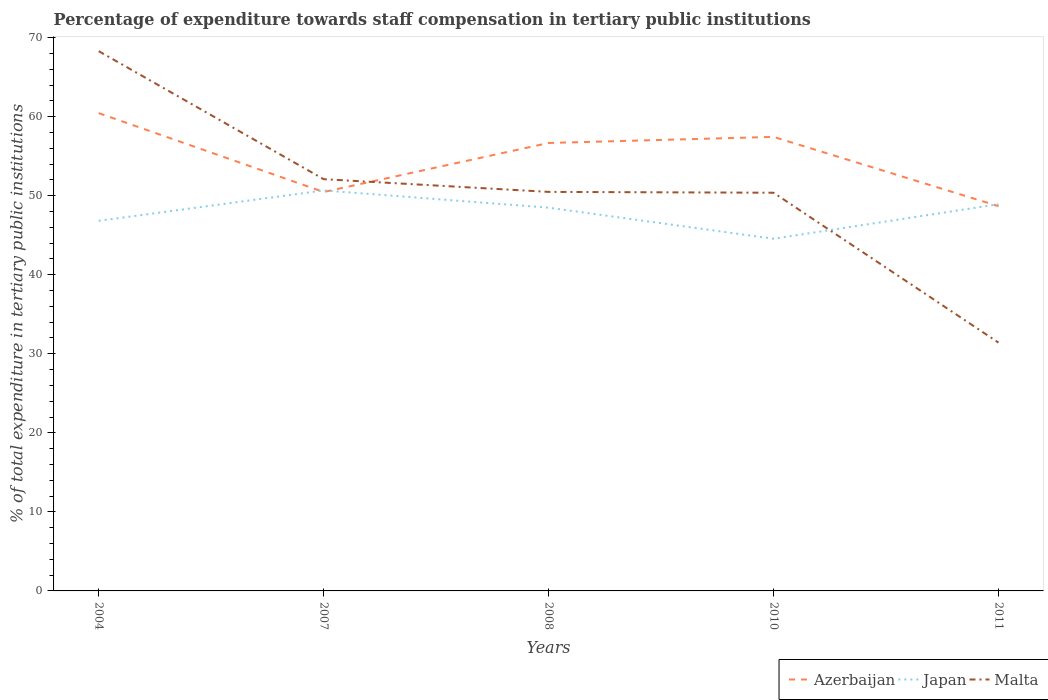How many different coloured lines are there?
Keep it short and to the point. 3. Does the line corresponding to Azerbaijan intersect with the line corresponding to Japan?
Provide a short and direct response. Yes. Is the number of lines equal to the number of legend labels?
Keep it short and to the point. Yes. Across all years, what is the maximum percentage of expenditure towards staff compensation in Malta?
Keep it short and to the point. 31.41. In which year was the percentage of expenditure towards staff compensation in Japan maximum?
Your response must be concise. 2010. What is the total percentage of expenditure towards staff compensation in Azerbaijan in the graph?
Offer a terse response. -6.2. What is the difference between the highest and the second highest percentage of expenditure towards staff compensation in Malta?
Offer a terse response. 36.88. What is the difference between the highest and the lowest percentage of expenditure towards staff compensation in Japan?
Give a very brief answer. 3. Is the percentage of expenditure towards staff compensation in Malta strictly greater than the percentage of expenditure towards staff compensation in Japan over the years?
Give a very brief answer. No. How many lines are there?
Offer a terse response. 3. How many years are there in the graph?
Your answer should be compact. 5. What is the difference between two consecutive major ticks on the Y-axis?
Provide a short and direct response. 10. Where does the legend appear in the graph?
Give a very brief answer. Bottom right. How many legend labels are there?
Your answer should be very brief. 3. What is the title of the graph?
Make the answer very short. Percentage of expenditure towards staff compensation in tertiary public institutions. Does "Bahamas" appear as one of the legend labels in the graph?
Your response must be concise. No. What is the label or title of the X-axis?
Offer a very short reply. Years. What is the label or title of the Y-axis?
Your answer should be compact. % of total expenditure in tertiary public institutions. What is the % of total expenditure in tertiary public institutions of Azerbaijan in 2004?
Give a very brief answer. 60.45. What is the % of total expenditure in tertiary public institutions of Japan in 2004?
Offer a very short reply. 46.82. What is the % of total expenditure in tertiary public institutions in Malta in 2004?
Give a very brief answer. 68.29. What is the % of total expenditure in tertiary public institutions of Azerbaijan in 2007?
Make the answer very short. 50.47. What is the % of total expenditure in tertiary public institutions in Japan in 2007?
Your answer should be very brief. 50.67. What is the % of total expenditure in tertiary public institutions in Malta in 2007?
Make the answer very short. 52.09. What is the % of total expenditure in tertiary public institutions of Azerbaijan in 2008?
Ensure brevity in your answer.  56.67. What is the % of total expenditure in tertiary public institutions in Japan in 2008?
Give a very brief answer. 48.49. What is the % of total expenditure in tertiary public institutions of Malta in 2008?
Offer a terse response. 50.48. What is the % of total expenditure in tertiary public institutions in Azerbaijan in 2010?
Offer a very short reply. 57.44. What is the % of total expenditure in tertiary public institutions of Japan in 2010?
Provide a short and direct response. 44.56. What is the % of total expenditure in tertiary public institutions in Malta in 2010?
Make the answer very short. 50.38. What is the % of total expenditure in tertiary public institutions in Azerbaijan in 2011?
Offer a very short reply. 48.68. What is the % of total expenditure in tertiary public institutions in Japan in 2011?
Your answer should be compact. 48.92. What is the % of total expenditure in tertiary public institutions of Malta in 2011?
Give a very brief answer. 31.41. Across all years, what is the maximum % of total expenditure in tertiary public institutions of Azerbaijan?
Provide a succinct answer. 60.45. Across all years, what is the maximum % of total expenditure in tertiary public institutions of Japan?
Offer a very short reply. 50.67. Across all years, what is the maximum % of total expenditure in tertiary public institutions in Malta?
Keep it short and to the point. 68.29. Across all years, what is the minimum % of total expenditure in tertiary public institutions of Azerbaijan?
Keep it short and to the point. 48.68. Across all years, what is the minimum % of total expenditure in tertiary public institutions of Japan?
Ensure brevity in your answer.  44.56. Across all years, what is the minimum % of total expenditure in tertiary public institutions in Malta?
Make the answer very short. 31.41. What is the total % of total expenditure in tertiary public institutions of Azerbaijan in the graph?
Keep it short and to the point. 273.71. What is the total % of total expenditure in tertiary public institutions in Japan in the graph?
Make the answer very short. 239.46. What is the total % of total expenditure in tertiary public institutions of Malta in the graph?
Provide a short and direct response. 252.66. What is the difference between the % of total expenditure in tertiary public institutions of Azerbaijan in 2004 and that in 2007?
Your answer should be compact. 9.98. What is the difference between the % of total expenditure in tertiary public institutions of Japan in 2004 and that in 2007?
Offer a terse response. -3.84. What is the difference between the % of total expenditure in tertiary public institutions in Malta in 2004 and that in 2007?
Your answer should be compact. 16.2. What is the difference between the % of total expenditure in tertiary public institutions of Azerbaijan in 2004 and that in 2008?
Give a very brief answer. 3.78. What is the difference between the % of total expenditure in tertiary public institutions of Japan in 2004 and that in 2008?
Make the answer very short. -1.66. What is the difference between the % of total expenditure in tertiary public institutions of Malta in 2004 and that in 2008?
Provide a short and direct response. 17.81. What is the difference between the % of total expenditure in tertiary public institutions of Azerbaijan in 2004 and that in 2010?
Keep it short and to the point. 3.01. What is the difference between the % of total expenditure in tertiary public institutions of Japan in 2004 and that in 2010?
Offer a very short reply. 2.27. What is the difference between the % of total expenditure in tertiary public institutions of Malta in 2004 and that in 2010?
Your response must be concise. 17.91. What is the difference between the % of total expenditure in tertiary public institutions of Azerbaijan in 2004 and that in 2011?
Offer a very short reply. 11.77. What is the difference between the % of total expenditure in tertiary public institutions in Japan in 2004 and that in 2011?
Give a very brief answer. -2.1. What is the difference between the % of total expenditure in tertiary public institutions in Malta in 2004 and that in 2011?
Give a very brief answer. 36.88. What is the difference between the % of total expenditure in tertiary public institutions in Azerbaijan in 2007 and that in 2008?
Offer a very short reply. -6.2. What is the difference between the % of total expenditure in tertiary public institutions in Japan in 2007 and that in 2008?
Your answer should be compact. 2.18. What is the difference between the % of total expenditure in tertiary public institutions in Malta in 2007 and that in 2008?
Your answer should be compact. 1.61. What is the difference between the % of total expenditure in tertiary public institutions of Azerbaijan in 2007 and that in 2010?
Your response must be concise. -6.97. What is the difference between the % of total expenditure in tertiary public institutions of Japan in 2007 and that in 2010?
Provide a succinct answer. 6.11. What is the difference between the % of total expenditure in tertiary public institutions in Malta in 2007 and that in 2010?
Offer a terse response. 1.72. What is the difference between the % of total expenditure in tertiary public institutions in Azerbaijan in 2007 and that in 2011?
Make the answer very short. 1.79. What is the difference between the % of total expenditure in tertiary public institutions of Japan in 2007 and that in 2011?
Keep it short and to the point. 1.74. What is the difference between the % of total expenditure in tertiary public institutions in Malta in 2007 and that in 2011?
Ensure brevity in your answer.  20.68. What is the difference between the % of total expenditure in tertiary public institutions of Azerbaijan in 2008 and that in 2010?
Your answer should be very brief. -0.77. What is the difference between the % of total expenditure in tertiary public institutions of Japan in 2008 and that in 2010?
Your response must be concise. 3.93. What is the difference between the % of total expenditure in tertiary public institutions in Malta in 2008 and that in 2010?
Offer a very short reply. 0.11. What is the difference between the % of total expenditure in tertiary public institutions in Azerbaijan in 2008 and that in 2011?
Give a very brief answer. 7.99. What is the difference between the % of total expenditure in tertiary public institutions in Japan in 2008 and that in 2011?
Offer a very short reply. -0.44. What is the difference between the % of total expenditure in tertiary public institutions of Malta in 2008 and that in 2011?
Provide a short and direct response. 19.07. What is the difference between the % of total expenditure in tertiary public institutions in Azerbaijan in 2010 and that in 2011?
Your answer should be very brief. 8.76. What is the difference between the % of total expenditure in tertiary public institutions in Japan in 2010 and that in 2011?
Ensure brevity in your answer.  -4.37. What is the difference between the % of total expenditure in tertiary public institutions of Malta in 2010 and that in 2011?
Ensure brevity in your answer.  18.96. What is the difference between the % of total expenditure in tertiary public institutions in Azerbaijan in 2004 and the % of total expenditure in tertiary public institutions in Japan in 2007?
Provide a short and direct response. 9.78. What is the difference between the % of total expenditure in tertiary public institutions in Azerbaijan in 2004 and the % of total expenditure in tertiary public institutions in Malta in 2007?
Provide a short and direct response. 8.36. What is the difference between the % of total expenditure in tertiary public institutions in Japan in 2004 and the % of total expenditure in tertiary public institutions in Malta in 2007?
Your answer should be very brief. -5.27. What is the difference between the % of total expenditure in tertiary public institutions of Azerbaijan in 2004 and the % of total expenditure in tertiary public institutions of Japan in 2008?
Provide a short and direct response. 11.96. What is the difference between the % of total expenditure in tertiary public institutions in Azerbaijan in 2004 and the % of total expenditure in tertiary public institutions in Malta in 2008?
Give a very brief answer. 9.97. What is the difference between the % of total expenditure in tertiary public institutions in Japan in 2004 and the % of total expenditure in tertiary public institutions in Malta in 2008?
Provide a succinct answer. -3.66. What is the difference between the % of total expenditure in tertiary public institutions in Azerbaijan in 2004 and the % of total expenditure in tertiary public institutions in Japan in 2010?
Offer a terse response. 15.89. What is the difference between the % of total expenditure in tertiary public institutions of Azerbaijan in 2004 and the % of total expenditure in tertiary public institutions of Malta in 2010?
Give a very brief answer. 10.07. What is the difference between the % of total expenditure in tertiary public institutions in Japan in 2004 and the % of total expenditure in tertiary public institutions in Malta in 2010?
Your answer should be compact. -3.55. What is the difference between the % of total expenditure in tertiary public institutions of Azerbaijan in 2004 and the % of total expenditure in tertiary public institutions of Japan in 2011?
Your response must be concise. 11.53. What is the difference between the % of total expenditure in tertiary public institutions of Azerbaijan in 2004 and the % of total expenditure in tertiary public institutions of Malta in 2011?
Provide a short and direct response. 29.04. What is the difference between the % of total expenditure in tertiary public institutions of Japan in 2004 and the % of total expenditure in tertiary public institutions of Malta in 2011?
Keep it short and to the point. 15.41. What is the difference between the % of total expenditure in tertiary public institutions of Azerbaijan in 2007 and the % of total expenditure in tertiary public institutions of Japan in 2008?
Your answer should be compact. 1.98. What is the difference between the % of total expenditure in tertiary public institutions in Azerbaijan in 2007 and the % of total expenditure in tertiary public institutions in Malta in 2008?
Your answer should be very brief. -0.01. What is the difference between the % of total expenditure in tertiary public institutions of Japan in 2007 and the % of total expenditure in tertiary public institutions of Malta in 2008?
Provide a short and direct response. 0.18. What is the difference between the % of total expenditure in tertiary public institutions of Azerbaijan in 2007 and the % of total expenditure in tertiary public institutions of Japan in 2010?
Your response must be concise. 5.91. What is the difference between the % of total expenditure in tertiary public institutions in Azerbaijan in 2007 and the % of total expenditure in tertiary public institutions in Malta in 2010?
Offer a terse response. 0.09. What is the difference between the % of total expenditure in tertiary public institutions of Japan in 2007 and the % of total expenditure in tertiary public institutions of Malta in 2010?
Give a very brief answer. 0.29. What is the difference between the % of total expenditure in tertiary public institutions of Azerbaijan in 2007 and the % of total expenditure in tertiary public institutions of Japan in 2011?
Your answer should be very brief. 1.54. What is the difference between the % of total expenditure in tertiary public institutions of Azerbaijan in 2007 and the % of total expenditure in tertiary public institutions of Malta in 2011?
Your answer should be very brief. 19.05. What is the difference between the % of total expenditure in tertiary public institutions in Japan in 2007 and the % of total expenditure in tertiary public institutions in Malta in 2011?
Keep it short and to the point. 19.25. What is the difference between the % of total expenditure in tertiary public institutions in Azerbaijan in 2008 and the % of total expenditure in tertiary public institutions in Japan in 2010?
Make the answer very short. 12.11. What is the difference between the % of total expenditure in tertiary public institutions in Azerbaijan in 2008 and the % of total expenditure in tertiary public institutions in Malta in 2010?
Ensure brevity in your answer.  6.29. What is the difference between the % of total expenditure in tertiary public institutions in Japan in 2008 and the % of total expenditure in tertiary public institutions in Malta in 2010?
Provide a succinct answer. -1.89. What is the difference between the % of total expenditure in tertiary public institutions of Azerbaijan in 2008 and the % of total expenditure in tertiary public institutions of Japan in 2011?
Ensure brevity in your answer.  7.75. What is the difference between the % of total expenditure in tertiary public institutions in Azerbaijan in 2008 and the % of total expenditure in tertiary public institutions in Malta in 2011?
Make the answer very short. 25.26. What is the difference between the % of total expenditure in tertiary public institutions in Japan in 2008 and the % of total expenditure in tertiary public institutions in Malta in 2011?
Ensure brevity in your answer.  17.07. What is the difference between the % of total expenditure in tertiary public institutions in Azerbaijan in 2010 and the % of total expenditure in tertiary public institutions in Japan in 2011?
Make the answer very short. 8.52. What is the difference between the % of total expenditure in tertiary public institutions of Azerbaijan in 2010 and the % of total expenditure in tertiary public institutions of Malta in 2011?
Your answer should be very brief. 26.03. What is the difference between the % of total expenditure in tertiary public institutions in Japan in 2010 and the % of total expenditure in tertiary public institutions in Malta in 2011?
Your response must be concise. 13.14. What is the average % of total expenditure in tertiary public institutions of Azerbaijan per year?
Give a very brief answer. 54.74. What is the average % of total expenditure in tertiary public institutions in Japan per year?
Provide a succinct answer. 47.89. What is the average % of total expenditure in tertiary public institutions in Malta per year?
Provide a succinct answer. 50.53. In the year 2004, what is the difference between the % of total expenditure in tertiary public institutions in Azerbaijan and % of total expenditure in tertiary public institutions in Japan?
Give a very brief answer. 13.63. In the year 2004, what is the difference between the % of total expenditure in tertiary public institutions in Azerbaijan and % of total expenditure in tertiary public institutions in Malta?
Your answer should be compact. -7.84. In the year 2004, what is the difference between the % of total expenditure in tertiary public institutions of Japan and % of total expenditure in tertiary public institutions of Malta?
Keep it short and to the point. -21.47. In the year 2007, what is the difference between the % of total expenditure in tertiary public institutions of Azerbaijan and % of total expenditure in tertiary public institutions of Japan?
Offer a terse response. -0.2. In the year 2007, what is the difference between the % of total expenditure in tertiary public institutions of Azerbaijan and % of total expenditure in tertiary public institutions of Malta?
Your response must be concise. -1.62. In the year 2007, what is the difference between the % of total expenditure in tertiary public institutions of Japan and % of total expenditure in tertiary public institutions of Malta?
Ensure brevity in your answer.  -1.42. In the year 2008, what is the difference between the % of total expenditure in tertiary public institutions of Azerbaijan and % of total expenditure in tertiary public institutions of Japan?
Provide a succinct answer. 8.19. In the year 2008, what is the difference between the % of total expenditure in tertiary public institutions of Azerbaijan and % of total expenditure in tertiary public institutions of Malta?
Provide a succinct answer. 6.19. In the year 2008, what is the difference between the % of total expenditure in tertiary public institutions in Japan and % of total expenditure in tertiary public institutions in Malta?
Your response must be concise. -2. In the year 2010, what is the difference between the % of total expenditure in tertiary public institutions of Azerbaijan and % of total expenditure in tertiary public institutions of Japan?
Your response must be concise. 12.88. In the year 2010, what is the difference between the % of total expenditure in tertiary public institutions of Azerbaijan and % of total expenditure in tertiary public institutions of Malta?
Give a very brief answer. 7.06. In the year 2010, what is the difference between the % of total expenditure in tertiary public institutions of Japan and % of total expenditure in tertiary public institutions of Malta?
Keep it short and to the point. -5.82. In the year 2011, what is the difference between the % of total expenditure in tertiary public institutions in Azerbaijan and % of total expenditure in tertiary public institutions in Japan?
Ensure brevity in your answer.  -0.25. In the year 2011, what is the difference between the % of total expenditure in tertiary public institutions of Azerbaijan and % of total expenditure in tertiary public institutions of Malta?
Your answer should be compact. 17.26. In the year 2011, what is the difference between the % of total expenditure in tertiary public institutions in Japan and % of total expenditure in tertiary public institutions in Malta?
Your response must be concise. 17.51. What is the ratio of the % of total expenditure in tertiary public institutions of Azerbaijan in 2004 to that in 2007?
Your response must be concise. 1.2. What is the ratio of the % of total expenditure in tertiary public institutions in Japan in 2004 to that in 2007?
Keep it short and to the point. 0.92. What is the ratio of the % of total expenditure in tertiary public institutions in Malta in 2004 to that in 2007?
Offer a terse response. 1.31. What is the ratio of the % of total expenditure in tertiary public institutions of Azerbaijan in 2004 to that in 2008?
Ensure brevity in your answer.  1.07. What is the ratio of the % of total expenditure in tertiary public institutions in Japan in 2004 to that in 2008?
Your answer should be compact. 0.97. What is the ratio of the % of total expenditure in tertiary public institutions in Malta in 2004 to that in 2008?
Offer a terse response. 1.35. What is the ratio of the % of total expenditure in tertiary public institutions in Azerbaijan in 2004 to that in 2010?
Offer a very short reply. 1.05. What is the ratio of the % of total expenditure in tertiary public institutions of Japan in 2004 to that in 2010?
Offer a terse response. 1.05. What is the ratio of the % of total expenditure in tertiary public institutions in Malta in 2004 to that in 2010?
Your answer should be very brief. 1.36. What is the ratio of the % of total expenditure in tertiary public institutions in Azerbaijan in 2004 to that in 2011?
Offer a terse response. 1.24. What is the ratio of the % of total expenditure in tertiary public institutions of Japan in 2004 to that in 2011?
Provide a succinct answer. 0.96. What is the ratio of the % of total expenditure in tertiary public institutions in Malta in 2004 to that in 2011?
Your response must be concise. 2.17. What is the ratio of the % of total expenditure in tertiary public institutions in Azerbaijan in 2007 to that in 2008?
Your response must be concise. 0.89. What is the ratio of the % of total expenditure in tertiary public institutions in Japan in 2007 to that in 2008?
Your response must be concise. 1.04. What is the ratio of the % of total expenditure in tertiary public institutions of Malta in 2007 to that in 2008?
Offer a very short reply. 1.03. What is the ratio of the % of total expenditure in tertiary public institutions in Azerbaijan in 2007 to that in 2010?
Your answer should be very brief. 0.88. What is the ratio of the % of total expenditure in tertiary public institutions of Japan in 2007 to that in 2010?
Offer a very short reply. 1.14. What is the ratio of the % of total expenditure in tertiary public institutions in Malta in 2007 to that in 2010?
Your answer should be compact. 1.03. What is the ratio of the % of total expenditure in tertiary public institutions of Azerbaijan in 2007 to that in 2011?
Offer a terse response. 1.04. What is the ratio of the % of total expenditure in tertiary public institutions of Japan in 2007 to that in 2011?
Make the answer very short. 1.04. What is the ratio of the % of total expenditure in tertiary public institutions in Malta in 2007 to that in 2011?
Provide a short and direct response. 1.66. What is the ratio of the % of total expenditure in tertiary public institutions of Azerbaijan in 2008 to that in 2010?
Make the answer very short. 0.99. What is the ratio of the % of total expenditure in tertiary public institutions of Japan in 2008 to that in 2010?
Provide a short and direct response. 1.09. What is the ratio of the % of total expenditure in tertiary public institutions in Azerbaijan in 2008 to that in 2011?
Your response must be concise. 1.16. What is the ratio of the % of total expenditure in tertiary public institutions of Japan in 2008 to that in 2011?
Your answer should be compact. 0.99. What is the ratio of the % of total expenditure in tertiary public institutions of Malta in 2008 to that in 2011?
Provide a succinct answer. 1.61. What is the ratio of the % of total expenditure in tertiary public institutions of Azerbaijan in 2010 to that in 2011?
Provide a succinct answer. 1.18. What is the ratio of the % of total expenditure in tertiary public institutions of Japan in 2010 to that in 2011?
Provide a succinct answer. 0.91. What is the ratio of the % of total expenditure in tertiary public institutions in Malta in 2010 to that in 2011?
Provide a succinct answer. 1.6. What is the difference between the highest and the second highest % of total expenditure in tertiary public institutions of Azerbaijan?
Provide a short and direct response. 3.01. What is the difference between the highest and the second highest % of total expenditure in tertiary public institutions in Japan?
Your response must be concise. 1.74. What is the difference between the highest and the second highest % of total expenditure in tertiary public institutions in Malta?
Keep it short and to the point. 16.2. What is the difference between the highest and the lowest % of total expenditure in tertiary public institutions of Azerbaijan?
Provide a short and direct response. 11.77. What is the difference between the highest and the lowest % of total expenditure in tertiary public institutions in Japan?
Your answer should be very brief. 6.11. What is the difference between the highest and the lowest % of total expenditure in tertiary public institutions of Malta?
Your answer should be very brief. 36.88. 